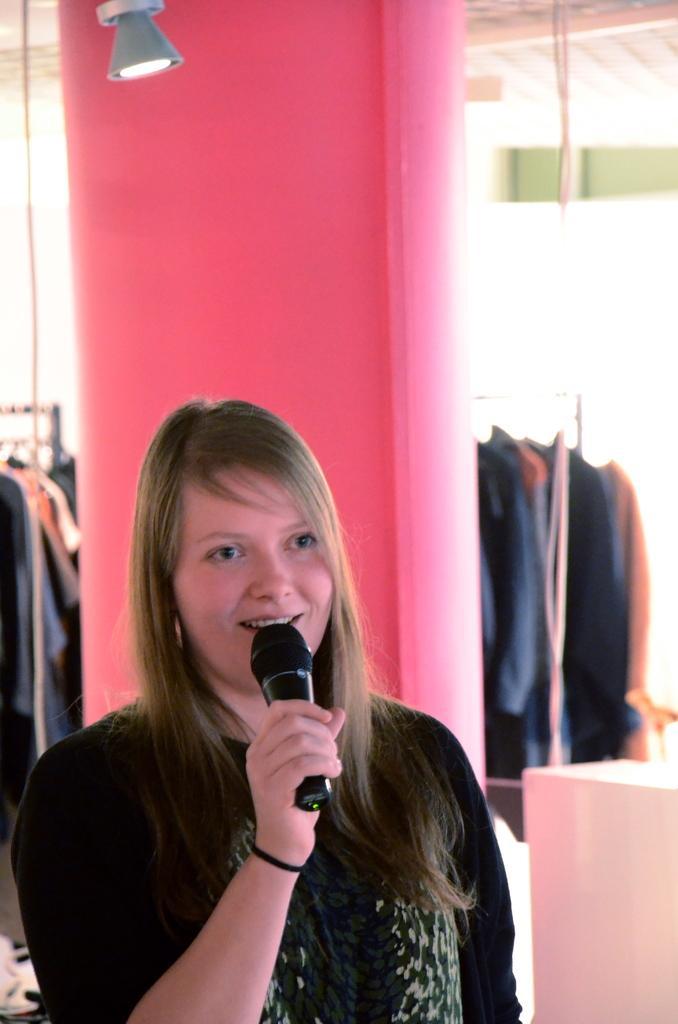Could you give a brief overview of what you see in this image? Here is a girl in black tee shirt who is holding a mike and behind her there is a pink color pillar and a lamp. 